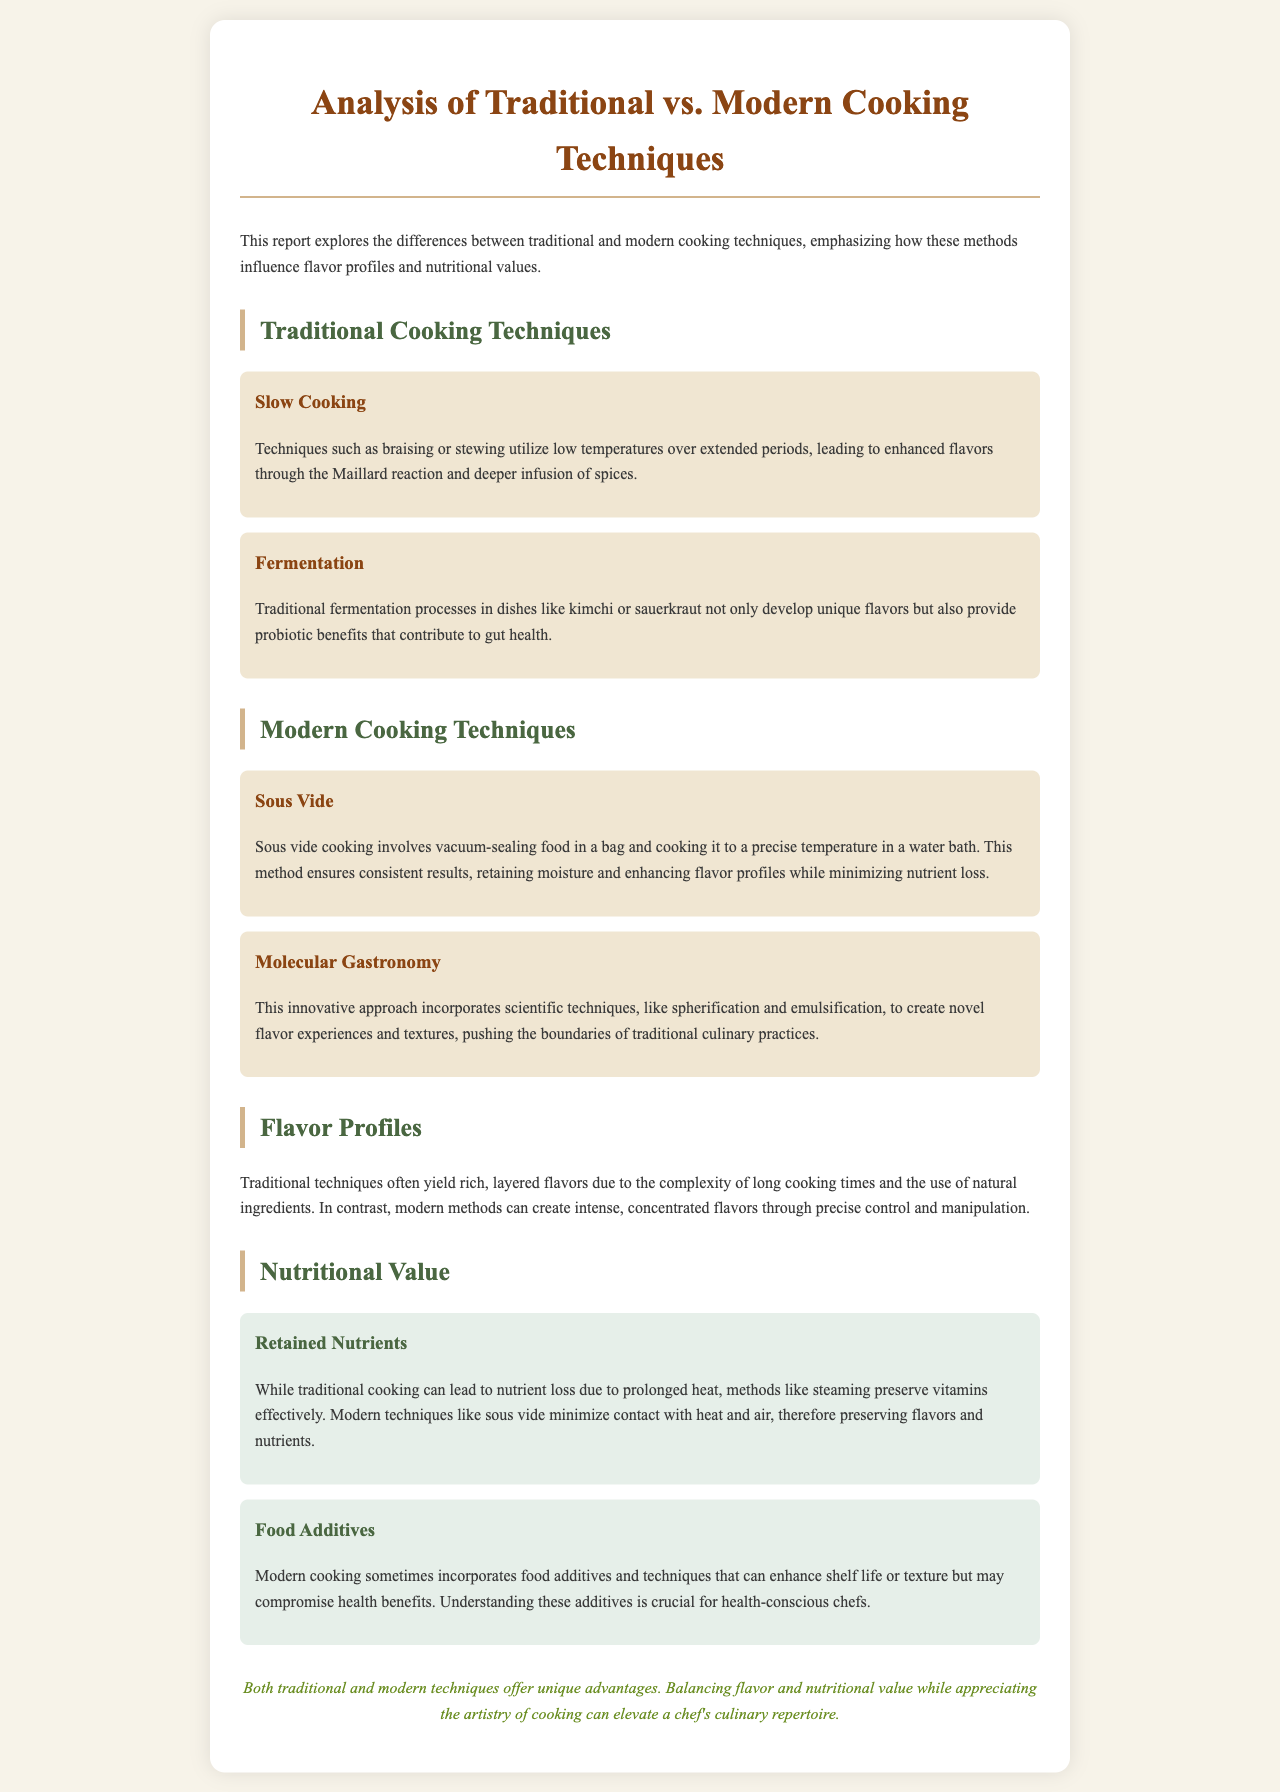What are two traditional cooking techniques mentioned? The document lists slow cooking and fermentation as traditional cooking techniques.
Answer: slow cooking, fermentation What is the main benefit of modern sous vide cooking? The report states that sous vide cooking retains moisture and enhances flavor profiles while minimizing nutrient loss.
Answer: retains moisture Which innovative approach incorporates scientific techniques? The document mentions molecular gastronomy as an innovative approach that uses scientific techniques like spherification and emulsification.
Answer: molecular gastronomy What flavor characteristics are typical of traditional cooking techniques? Traditional techniques yield rich, layered flavors due to long cooking times and natural ingredients.
Answer: rich, layered flavors Which cooking method is noted for preserving vitamins effectively? The report highlights that steaming preserves vitamins effectively despite traditional cooking methods leading to some nutrient loss.
Answer: steaming What is a key concern regarding food additives in modern cooking? The document points out that modern cooking sometimes incorporates additives that may compromise health benefits.
Answer: health benefits How do traditional techniques typically affect nutritional value? The report mentions that traditional cooking can lead to nutrient loss due to prolonged heat.
Answer: nutrient loss What is emphasized as essential for health-conscious chefs? Understanding food additives is noted as crucial for health-conscious chefs in the document.
Answer: understanding food additives 